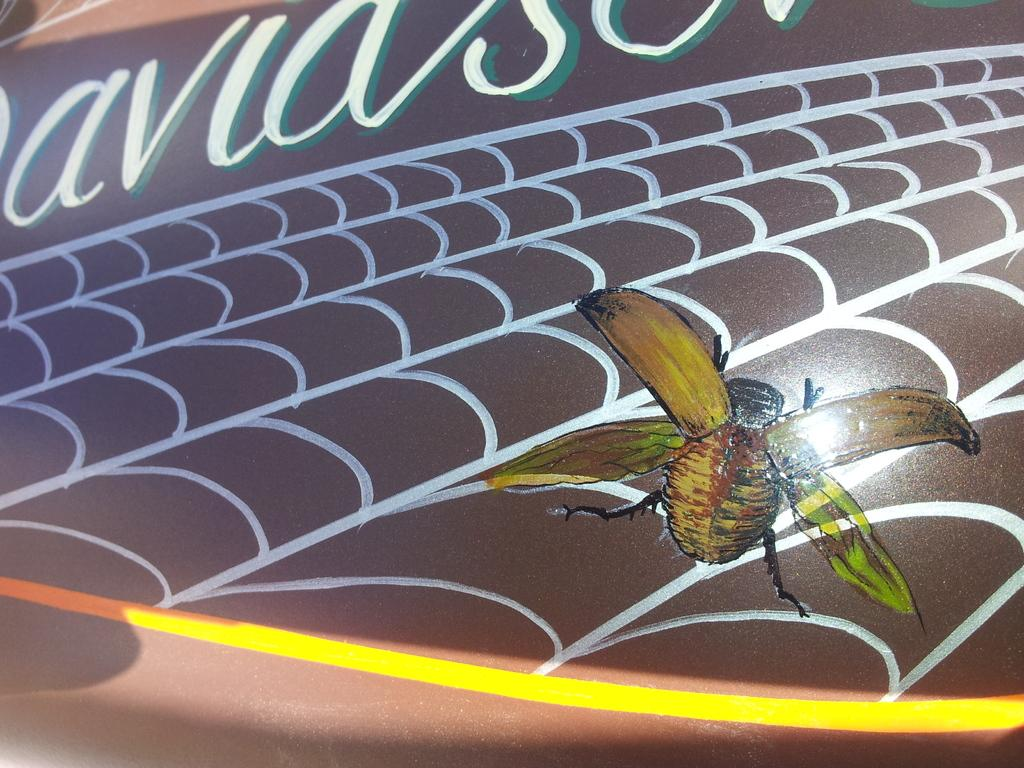What is depicted in the painting in the image? There is a painting of an insect in the image. Can you describe any design elements in the image? There is some design in the image. What type of text can be seen in the image? There is some text on a surface in the image. How many friends are visible in the image? There are no friends depicted in the image; it features a painting of an insect and other design elements. What type of eggs can be seen in the image? There are no eggs present in the image. 